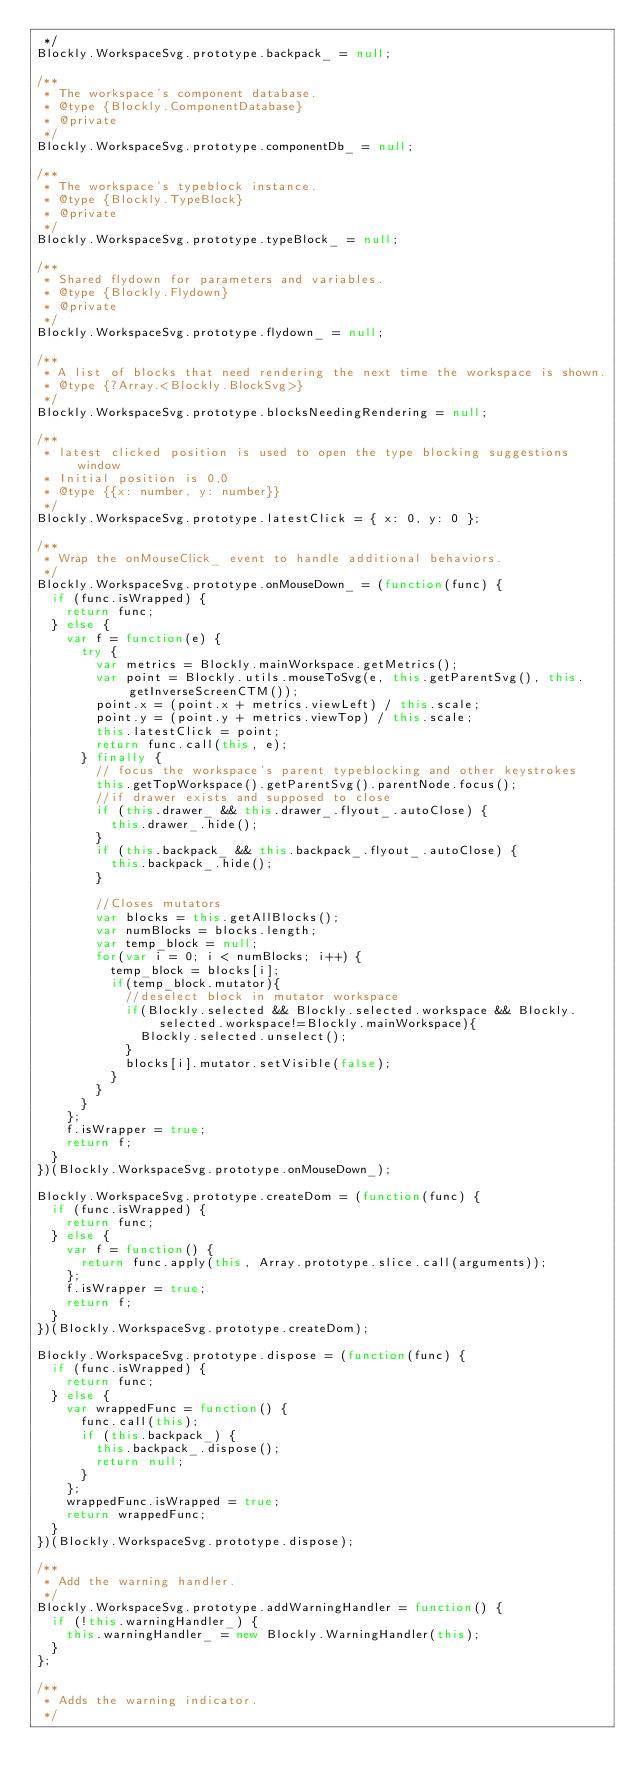Convert code to text. <code><loc_0><loc_0><loc_500><loc_500><_JavaScript_> */
Blockly.WorkspaceSvg.prototype.backpack_ = null;

/**
 * The workspace's component database.
 * @type {Blockly.ComponentDatabase}
 * @private
 */
Blockly.WorkspaceSvg.prototype.componentDb_ = null;

/**
 * The workspace's typeblock instance.
 * @type {Blockly.TypeBlock}
 * @private
 */
Blockly.WorkspaceSvg.prototype.typeBlock_ = null;

/**
 * Shared flydown for parameters and variables.
 * @type {Blockly.Flydown}
 * @private
 */
Blockly.WorkspaceSvg.prototype.flydown_ = null;

/**
 * A list of blocks that need rendering the next time the workspace is shown.
 * @type {?Array.<Blockly.BlockSvg>}
 */
Blockly.WorkspaceSvg.prototype.blocksNeedingRendering = null;

/**
 * latest clicked position is used to open the type blocking suggestions window
 * Initial position is 0,0
 * @type {{x: number, y: number}}
 */
Blockly.WorkspaceSvg.prototype.latestClick = { x: 0, y: 0 };

/**
 * Wrap the onMouseClick_ event to handle additional behaviors.
 */
Blockly.WorkspaceSvg.prototype.onMouseDown_ = (function(func) {
  if (func.isWrapped) {
    return func;
  } else {
    var f = function(e) {
      try {
        var metrics = Blockly.mainWorkspace.getMetrics();
        var point = Blockly.utils.mouseToSvg(e, this.getParentSvg(), this.getInverseScreenCTM());
        point.x = (point.x + metrics.viewLeft) / this.scale;
        point.y = (point.y + metrics.viewTop) / this.scale;
        this.latestClick = point;
        return func.call(this, e);
      } finally {
        // focus the workspace's parent typeblocking and other keystrokes
        this.getTopWorkspace().getParentSvg().parentNode.focus();
        //if drawer exists and supposed to close
        if (this.drawer_ && this.drawer_.flyout_.autoClose) {
          this.drawer_.hide();
        }
        if (this.backpack_ && this.backpack_.flyout_.autoClose) {
          this.backpack_.hide();
        }

        //Closes mutators
        var blocks = this.getAllBlocks();
        var numBlocks = blocks.length;
        var temp_block = null;
        for(var i = 0; i < numBlocks; i++) {
          temp_block = blocks[i];
          if(temp_block.mutator){
            //deselect block in mutator workspace
            if(Blockly.selected && Blockly.selected.workspace && Blockly.selected.workspace!=Blockly.mainWorkspace){
              Blockly.selected.unselect();
            }
            blocks[i].mutator.setVisible(false);
          }
        }
      }
    };
    f.isWrapper = true;
    return f;
  }
})(Blockly.WorkspaceSvg.prototype.onMouseDown_);

Blockly.WorkspaceSvg.prototype.createDom = (function(func) {
  if (func.isWrapped) {
    return func;
  } else {
    var f = function() {
      return func.apply(this, Array.prototype.slice.call(arguments));
    };
    f.isWrapper = true;
    return f;
  }
})(Blockly.WorkspaceSvg.prototype.createDom);

Blockly.WorkspaceSvg.prototype.dispose = (function(func) {
  if (func.isWrapped) {
    return func;
  } else {
    var wrappedFunc = function() {
      func.call(this);
      if (this.backpack_) {
        this.backpack_.dispose();
        return null;
      }
    };
    wrappedFunc.isWrapped = true;
    return wrappedFunc;
  }
})(Blockly.WorkspaceSvg.prototype.dispose);

/**
 * Add the warning handler.
 */
Blockly.WorkspaceSvg.prototype.addWarningHandler = function() {
  if (!this.warningHandler_) {
    this.warningHandler_ = new Blockly.WarningHandler(this);
  }
};

/**
 * Adds the warning indicator.
 */</code> 